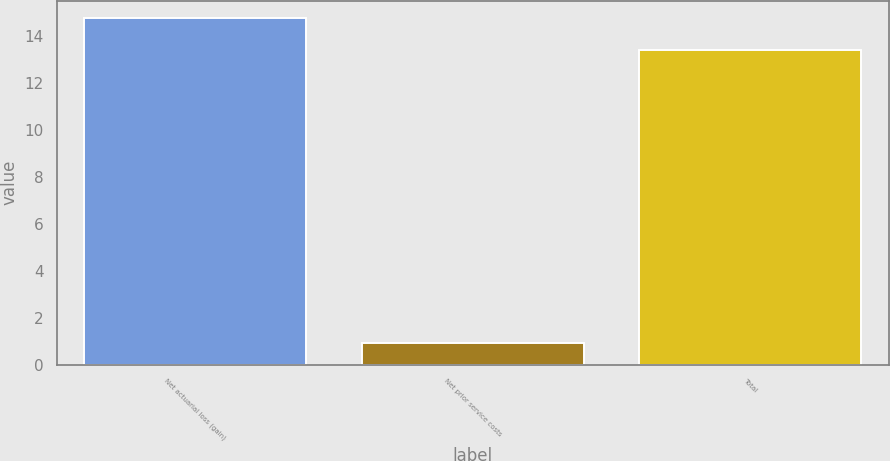<chart> <loc_0><loc_0><loc_500><loc_500><bar_chart><fcel>Net actuarial loss (gain)<fcel>Net prior service costs<fcel>Total<nl><fcel>14.74<fcel>0.9<fcel>13.4<nl></chart> 